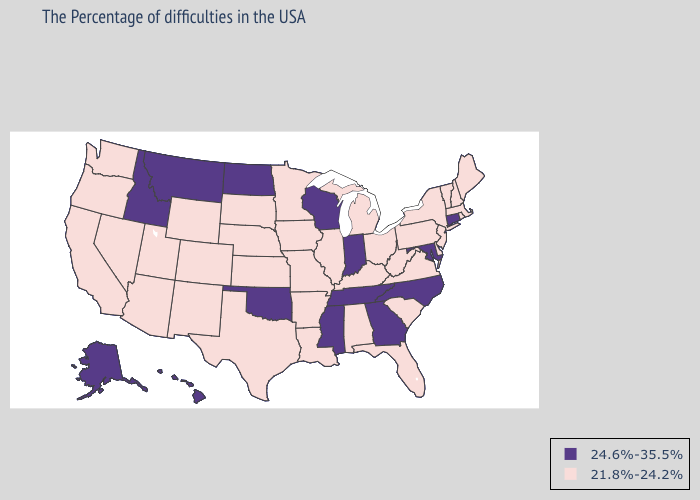Does Pennsylvania have the highest value in the Northeast?
Keep it brief. No. Which states have the lowest value in the South?
Write a very short answer. Delaware, Virginia, South Carolina, West Virginia, Florida, Kentucky, Alabama, Louisiana, Arkansas, Texas. Among the states that border New Mexico , does Oklahoma have the lowest value?
Concise answer only. No. What is the lowest value in the USA?
Quick response, please. 21.8%-24.2%. Does Connecticut have the highest value in the Northeast?
Give a very brief answer. Yes. Does Alaska have the lowest value in the West?
Concise answer only. No. Which states have the lowest value in the USA?
Answer briefly. Maine, Massachusetts, Rhode Island, New Hampshire, Vermont, New York, New Jersey, Delaware, Pennsylvania, Virginia, South Carolina, West Virginia, Ohio, Florida, Michigan, Kentucky, Alabama, Illinois, Louisiana, Missouri, Arkansas, Minnesota, Iowa, Kansas, Nebraska, Texas, South Dakota, Wyoming, Colorado, New Mexico, Utah, Arizona, Nevada, California, Washington, Oregon. Which states have the highest value in the USA?
Concise answer only. Connecticut, Maryland, North Carolina, Georgia, Indiana, Tennessee, Wisconsin, Mississippi, Oklahoma, North Dakota, Montana, Idaho, Alaska, Hawaii. What is the highest value in the USA?
Quick response, please. 24.6%-35.5%. What is the highest value in the MidWest ?
Give a very brief answer. 24.6%-35.5%. Does the map have missing data?
Short answer required. No. How many symbols are there in the legend?
Give a very brief answer. 2. Does the map have missing data?
Quick response, please. No. What is the lowest value in the USA?
Be succinct. 21.8%-24.2%. Does Kentucky have the lowest value in the USA?
Concise answer only. Yes. 